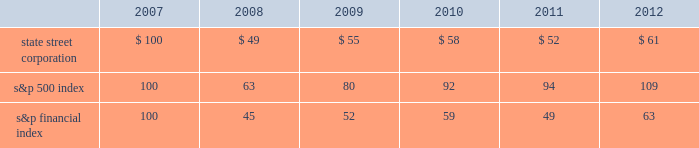Shareholder return performance presentation the graph presented below compares the cumulative total shareholder return on state street's common stock to the cumulative total return of the s&p 500 index and the s&p financial index over a five-year period .
The cumulative total shareholder return assumes the investment of $ 100 in state street common stock and in each index on december 31 , 2007 at the closing price on the last trading day of 2007 , and also assumes reinvestment of common stock dividends .
The s&p financial index is a publicly available measure of 80 of the standard & poor's 500 companies , representing 26 diversified financial services companies , 22 insurance companies , 17 real estate companies and 15 banking companies .
Comparison of five-year cumulative total shareholder return .

What is the roi of an investment in s&p500 index from 2007 to 2009? 
Computations: ((80 - 100) / 100)
Answer: -0.2. 